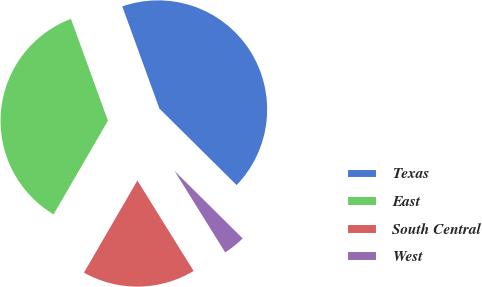Convert chart to OTSL. <chart><loc_0><loc_0><loc_500><loc_500><pie_chart><fcel>Texas<fcel>East<fcel>South Central<fcel>West<nl><fcel>42.97%<fcel>36.09%<fcel>17.22%<fcel>3.72%<nl></chart> 